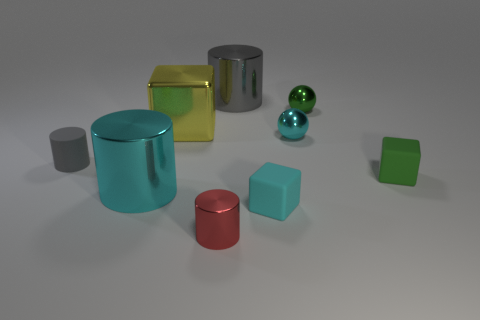Is the number of small green metal objects less than the number of tiny metallic objects?
Make the answer very short. Yes. There is a cylinder that is both to the left of the gray metallic thing and behind the tiny green block; what material is it made of?
Provide a succinct answer. Rubber. There is a big cylinder behind the cyan metallic sphere; are there any red cylinders that are behind it?
Make the answer very short. No. What number of things are big green shiny cylinders or cyan things?
Your response must be concise. 3. What is the shape of the tiny thing that is left of the gray shiny object and in front of the tiny green rubber cube?
Offer a terse response. Cylinder. Are the cyan thing on the left side of the big gray metallic cylinder and the big block made of the same material?
Give a very brief answer. Yes. How many objects are tiny gray objects or rubber things in front of the tiny gray matte thing?
Your response must be concise. 3. What color is the cube that is made of the same material as the red thing?
Your answer should be very brief. Yellow. What number of yellow blocks are the same material as the large gray thing?
Your response must be concise. 1. What number of brown rubber cylinders are there?
Ensure brevity in your answer.  0. 